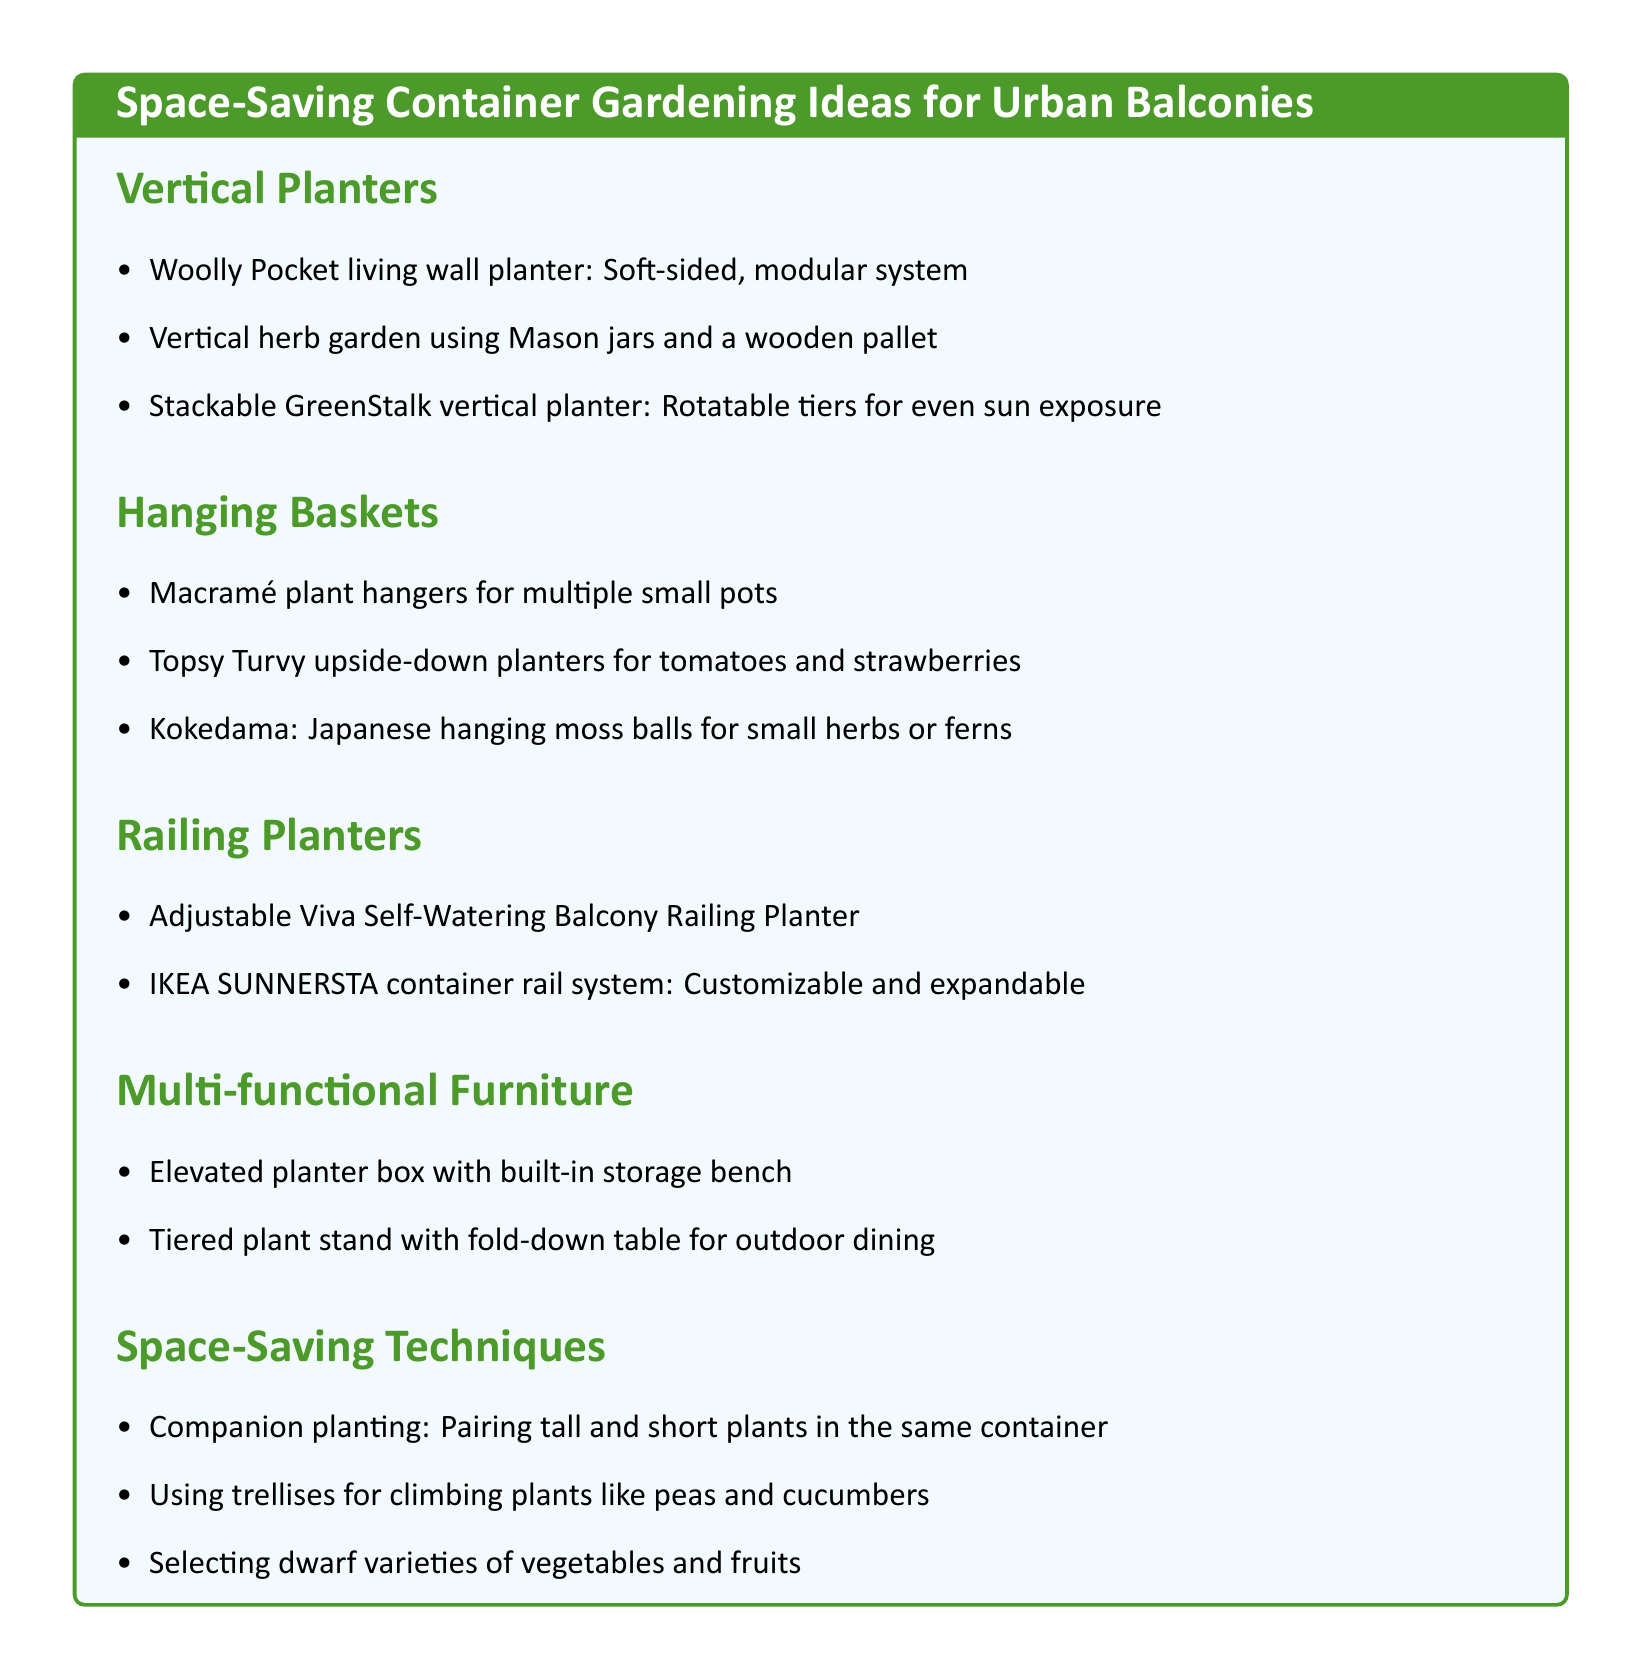What is one type of vertical planter mentioned? The document lists specific examples under the section for vertical planters, including the Woolly Pocket living wall planter.
Answer: Woolly Pocket living wall planter How many hanging basket ideas are provided? The document counts the number of items listed under the hanging baskets section, which includes three ideas.
Answer: 3 What is a feature of the Stackable GreenStalk vertical planter? The document describes the Stackable GreenStalk vertical planter by highlighting its rotatable tiers, which ensure even sun exposure.
Answer: Rotatable tiers for even sun exposure Which type of planter is adjustable and self-watering? The document specifies one of the railing planters as being both adjustable and self-watering, which is a feature worth noting.
Answer: Adjustable Viva Self-Watering Balcony Railing Planter What gardening technique involves pairing tall and short plants? The document discusses a space-saving technique under the space-saving techniques section that emphasizes companion planting.
Answer: Companion planting What multi-functional furniture item includes storage? One of the multi-functional furniture suggestions in the document refers to a planter box that comes with built-in storage capabilities.
Answer: Elevated planter box with built-in storage bench Which plant can be grown in Kokedama? The document mentions the use of Kokedama for specific small plants, indicating types that can thrive in this method.
Answer: Small herbs or ferns How many sections are there in the document? The total sections of gardening ideas listed in the document need to be counted for an accurate response.
Answer: 5 